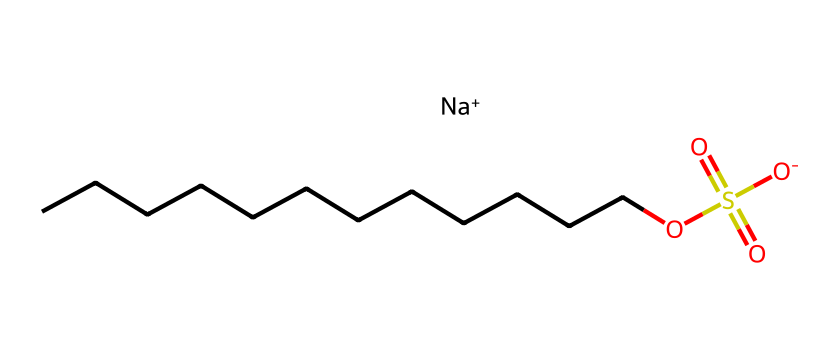What is the total number of carbon atoms in sodium dodecyl sulfate? By examining the SMILES representation, we can count the number of "C" characters. The part "CCCCCCCCCCCC" indicates there are 12 carbon atoms present.
Answer: 12 What type of ion is sodium in this chemical structure? The representation shows "[Na+]", indicating that sodium carries a positive charge, classifying it as a cation in the chemical.
Answer: cation How many sulfur atoms are present in sodium dodecyl sulfate? The SMILES notation has one "S" which indicates that there is one sulfur atom present in the structure.
Answer: 1 What is the functional group indicated by "S(=O)(=O)O" in the structure? The notation describes a sulfonate group, as it contains sulfur with double bonded oxygens and a hydroxy group, characteristic of sulfonates.
Answer: sulfonate What is the role of the hydrophobic chain in sodium dodecyl sulfate? The long hydrocarbon chain (CCCCCCCCCCCC) provides hydrophobic characteristics, allowing it to interact favorably with oils and grease, making it effective as a surfactant.
Answer: hydrophobic What is the charge of the sulfate group in this compound? The sulfate part "S(=O)(=O)O" indicates that it has a negative charge due to the sulfonate functionality in the compound's structure.
Answer: negative How does the presence of sodium ions affect the solubility of sodium dodecyl sulfate in water? The sodium ion contributes to the ionic nature of the compound, enhancing its solubility in water due to ionic interaction with polar water molecules.
Answer: increases solubility 